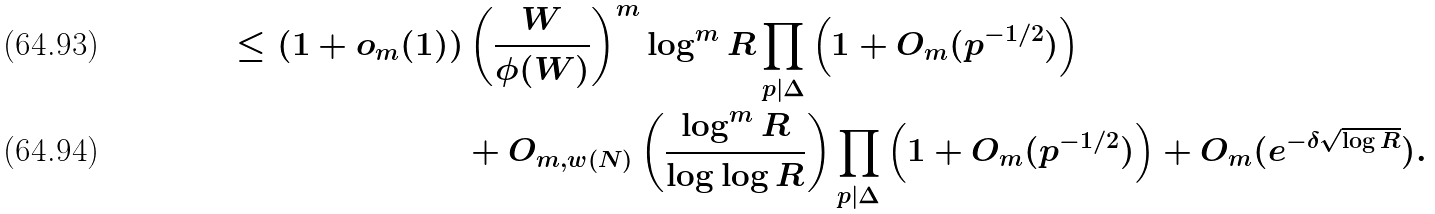<formula> <loc_0><loc_0><loc_500><loc_500>\leq ( 1 + o _ { m } ( 1 ) ) & \left ( \frac { W } { \phi ( W ) } \right ) ^ { m } \log ^ { m } R \prod _ { p | \Delta } \left ( 1 + O _ { m } ( p ^ { - 1 / 2 } ) \right ) \\ & + O _ { m , w ( N ) } \left ( \frac { \log ^ { m } R } { \log \log R } \right ) \prod _ { p | \Delta } \left ( 1 + O _ { m } ( p ^ { - 1 / 2 } ) \right ) + O _ { m } ( e ^ { - \delta \sqrt { \log R } } ) .</formula> 